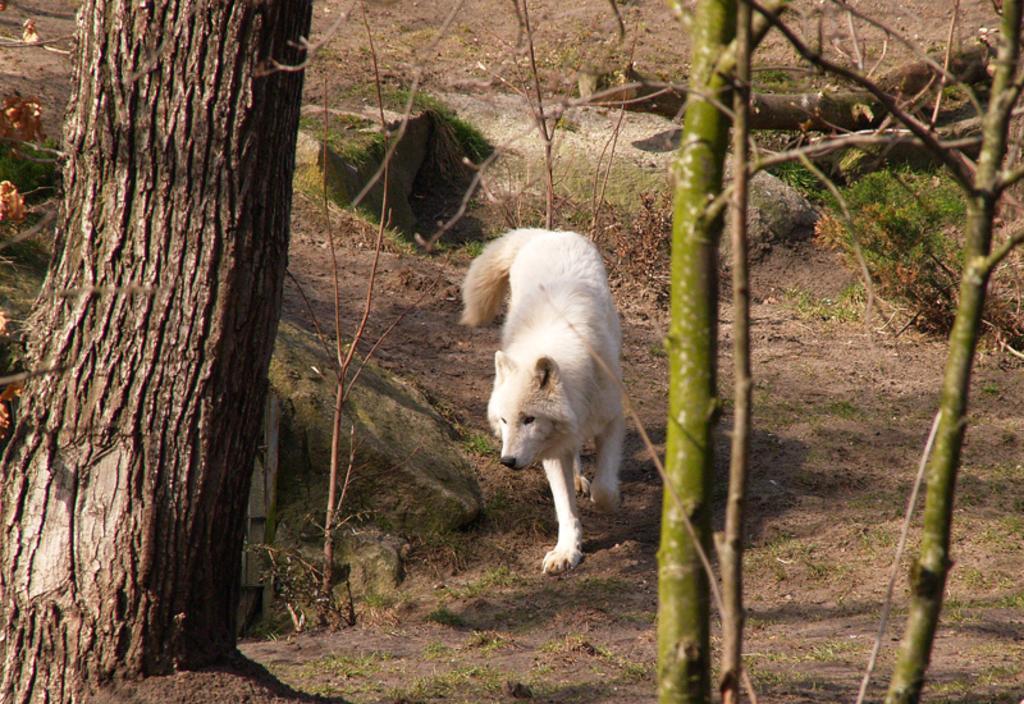How would you summarize this image in a sentence or two? This picture is clicked outside. In the center there is an animal walking on the ground. On the left we can see the trunk of the tree. On the right we can see the branches and stems of a tree. In the background we can see there are some objects on the ground. 